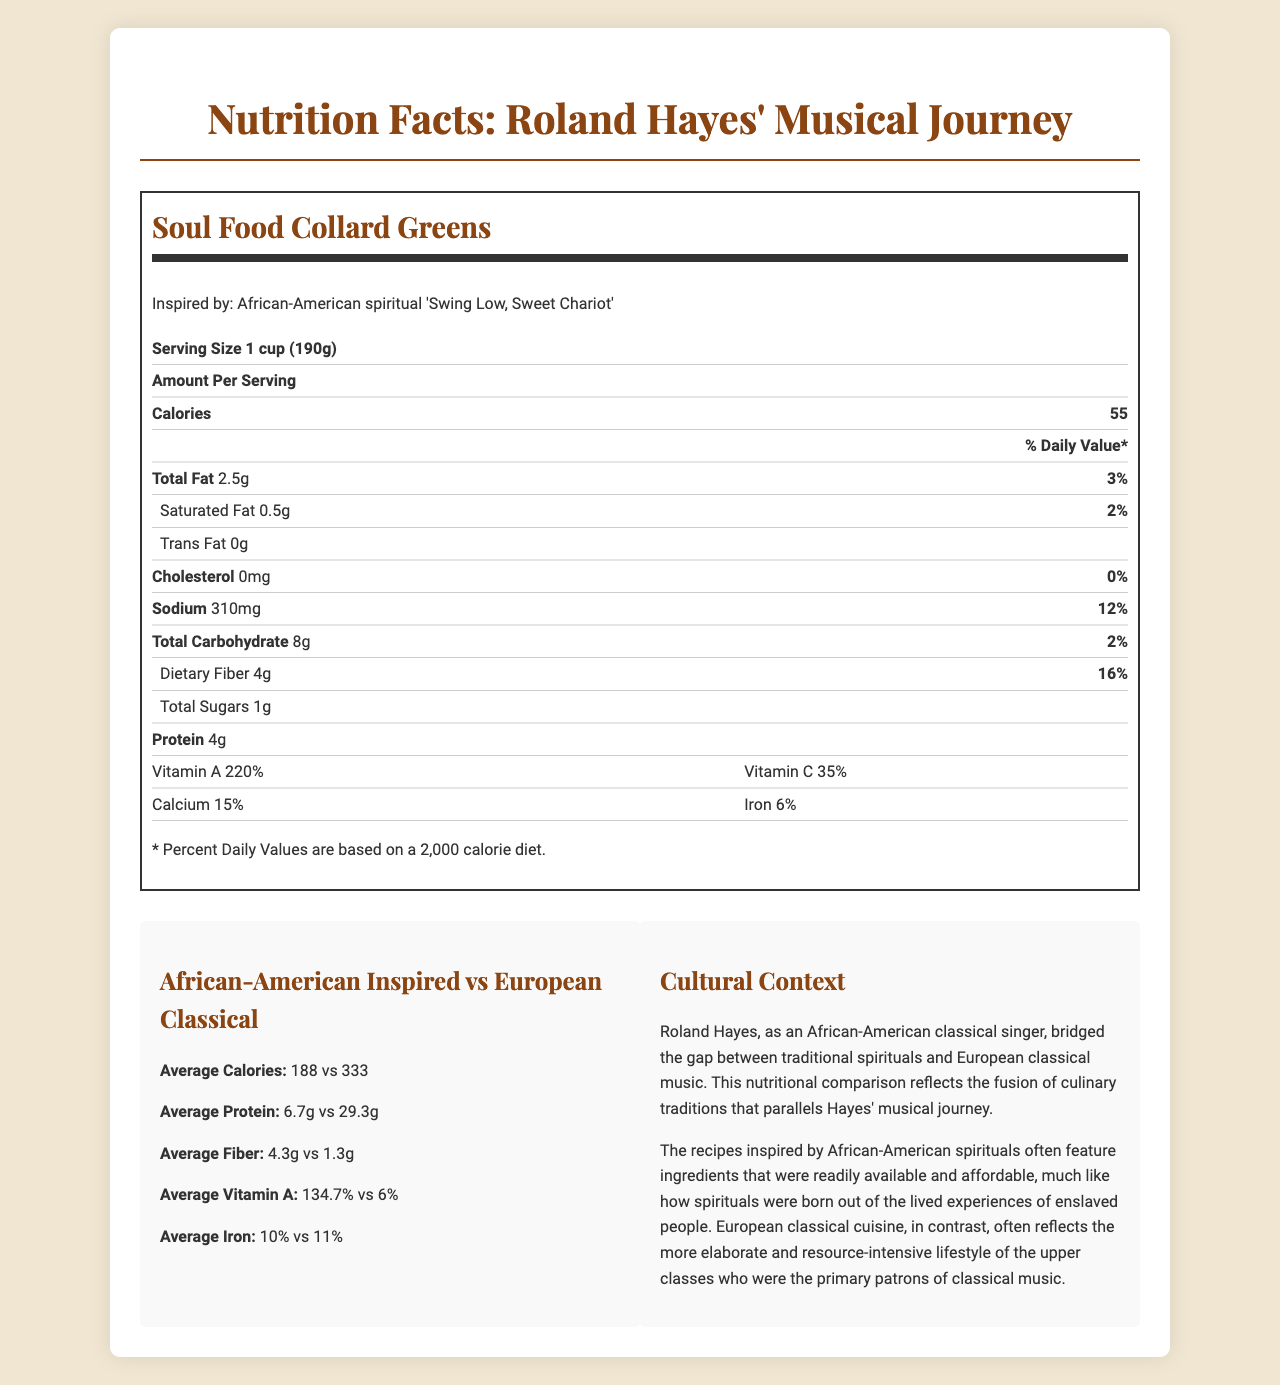What is the serving size for "Soul Food Collard Greens"? The serving size for each recipe is clearly mentioned in the document. For "Soul Food Collard Greens," it is 1 cup (190g).
Answer: 1 cup (190g) How many calories are in a slice of "Sweet Potato Pie"? The document states that one slice (120g) of "Sweet Potato Pie" contains 280 calories.
Answer: 280 Which recipe has the highest amount of dietary fiber per serving? "Hoppin' John" has 7g of dietary fiber per serving, which is higher than the dietary fiber content in the other recipes listed.
Answer: Hoppin' John What percentage of the daily value of Vitamin A does the "Sweet Potato Pie" provide? The document specifies that a serving of "Sweet Potato Pie" provides 180% of the daily value for Vitamin A.
Answer: 180% How much protein does "French Coq au Vin" contain? The "French Coq au Vin" recipe contains 32g of protein per serving.
Answer: 32g Which recipe has the highest sodium content? A. Soul Food Collard Greens B. Classical Beef Bourguignon C. Hoppin’ John D. Austrian Wiener Schnitzel The "Austrian Wiener Schnitzel" has the highest sodium content with 580mg per serving.
Answer: D. Austrian Wiener Schnitzel What is the average calorie content of African-American inspired recipes? i. 188 ii. 230 iii. 320 iv. 333 The document states that the average calorie content for African-American inspired recipes is 188.
Answer: i. 188 Does "Classical Beef Bourguignon" have more than 300 calories per serving? The "Classical Beef Bourguignon" contains 320 calories per serving, which is more than 300 calories.
Answer: Yes Summarize the main comparison points between African-American inspired recipes and European classical cuisine recipes. The nutritional information outlines that African-American inspired recipes are generally more nutritious in terms of fiber and vitamins but have lower protein content and calories compared to European classical cuisine. This comparison is linked to the cultural contexts and historical background of the ingredients used.
Answer: African-American inspired recipes tend to be lower in calories, protein, and sodium, but higher in dietary fiber and vitamin A compared to European classical cuisine recipes. This nutritional comparison reflects differing cultural and historical contexts where African-American recipes utilize more accessible, affordable ingredients, whereas European recipes often involve more elaborate, resource-intensive ingredients. Is there enough information to know the exact amount of calcium in "Classical Beef Bourguignon"? The document provides the percentage daily values for calcium but does not specify the exact milligrams for each recipe. Therefore, the exact amount of calcium in "Classical Beef Bourguignon" is not determined.
Answer: No Explain the cultural connection of Roland Hayes to the fusion of culinary traditions as described in the document. Roland Hayes' musical career exemplifies the blending of African-American spirituals with European classical music. The document draws a parallel to culinary traditions, comparing the nutritional elements of recipes inspired by these two cultural spheres, highlighting both historical context and modern implications.
Answer: Roland Hayes, as an African-American classical singer, bridged the gap between traditional spirituals and European classical music. This nutritional comparison reflects the fusion of culinary traditions that parallel Hayes' musical journey. 